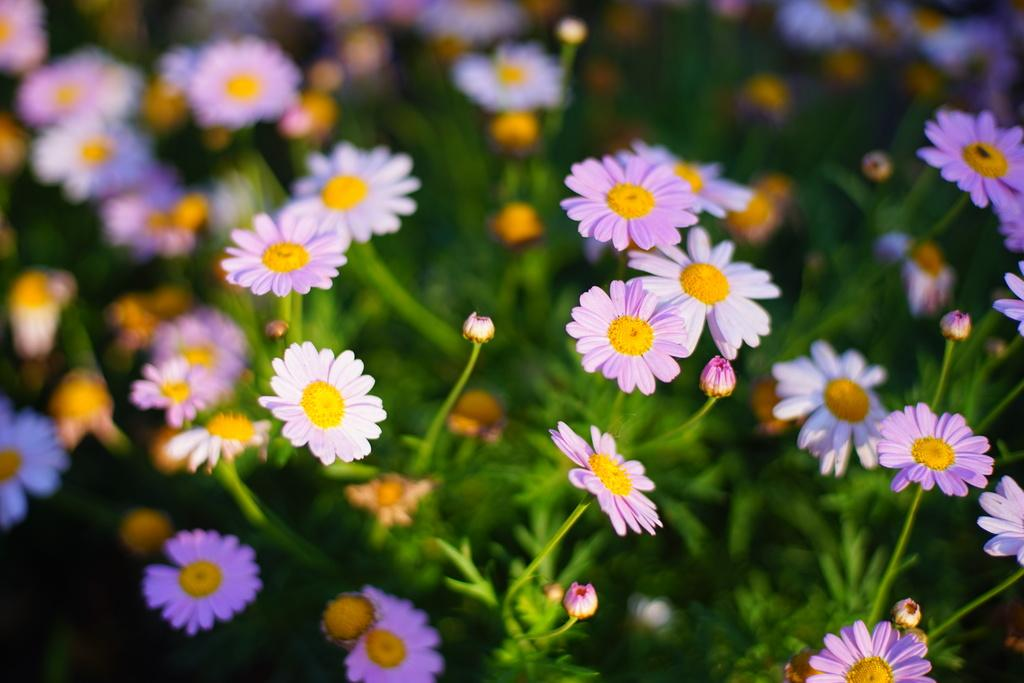What type of plants can be seen in the image? There are plants with flowers in the image. Can you describe the background of the image? The background of the image is blurry. What story is being told in the advertisement in the image? There is no advertisement present in the image, and therefore no story can be identified. 